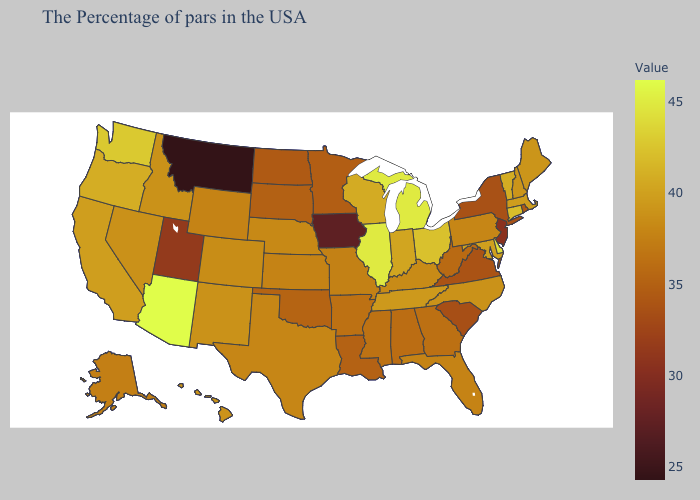Does Montana have the lowest value in the USA?
Be succinct. Yes. Among the states that border Michigan , which have the highest value?
Answer briefly. Ohio. Which states hav the highest value in the MidWest?
Concise answer only. Michigan, Illinois. Does Alabama have a lower value than New York?
Quick response, please. No. Does Arizona have the highest value in the USA?
Be succinct. Yes. Among the states that border Missouri , which have the highest value?
Keep it brief. Illinois. Which states hav the highest value in the South?
Give a very brief answer. Delaware. 